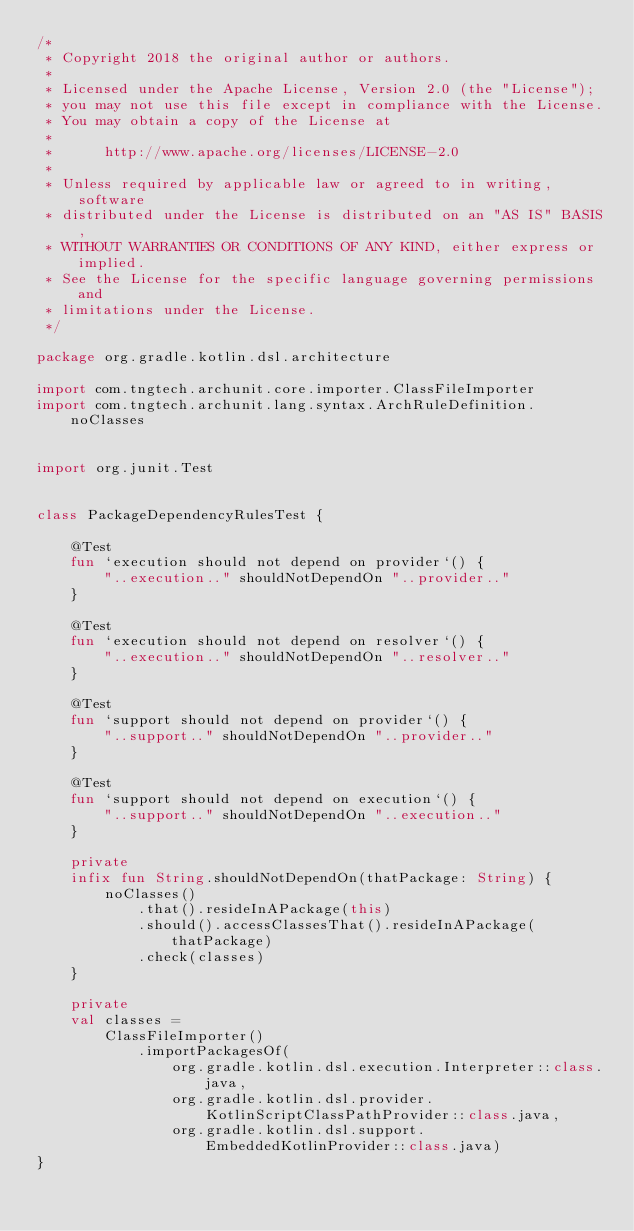<code> <loc_0><loc_0><loc_500><loc_500><_Kotlin_>/*
 * Copyright 2018 the original author or authors.
 *
 * Licensed under the Apache License, Version 2.0 (the "License");
 * you may not use this file except in compliance with the License.
 * You may obtain a copy of the License at
 *
 *      http://www.apache.org/licenses/LICENSE-2.0
 *
 * Unless required by applicable law or agreed to in writing, software
 * distributed under the License is distributed on an "AS IS" BASIS,
 * WITHOUT WARRANTIES OR CONDITIONS OF ANY KIND, either express or implied.
 * See the License for the specific language governing permissions and
 * limitations under the License.
 */

package org.gradle.kotlin.dsl.architecture

import com.tngtech.archunit.core.importer.ClassFileImporter
import com.tngtech.archunit.lang.syntax.ArchRuleDefinition.noClasses


import org.junit.Test


class PackageDependencyRulesTest {

    @Test
    fun `execution should not depend on provider`() {
        "..execution.." shouldNotDependOn "..provider.."
    }

    @Test
    fun `execution should not depend on resolver`() {
        "..execution.." shouldNotDependOn "..resolver.."
    }

    @Test
    fun `support should not depend on provider`() {
        "..support.." shouldNotDependOn "..provider.."
    }

    @Test
    fun `support should not depend on execution`() {
        "..support.." shouldNotDependOn "..execution.."
    }

    private
    infix fun String.shouldNotDependOn(thatPackage: String) {
        noClasses()
            .that().resideInAPackage(this)
            .should().accessClassesThat().resideInAPackage(thatPackage)
            .check(classes)
    }

    private
    val classes =
        ClassFileImporter()
            .importPackagesOf(
                org.gradle.kotlin.dsl.execution.Interpreter::class.java,
                org.gradle.kotlin.dsl.provider.KotlinScriptClassPathProvider::class.java,
                org.gradle.kotlin.dsl.support.EmbeddedKotlinProvider::class.java)
}
</code> 